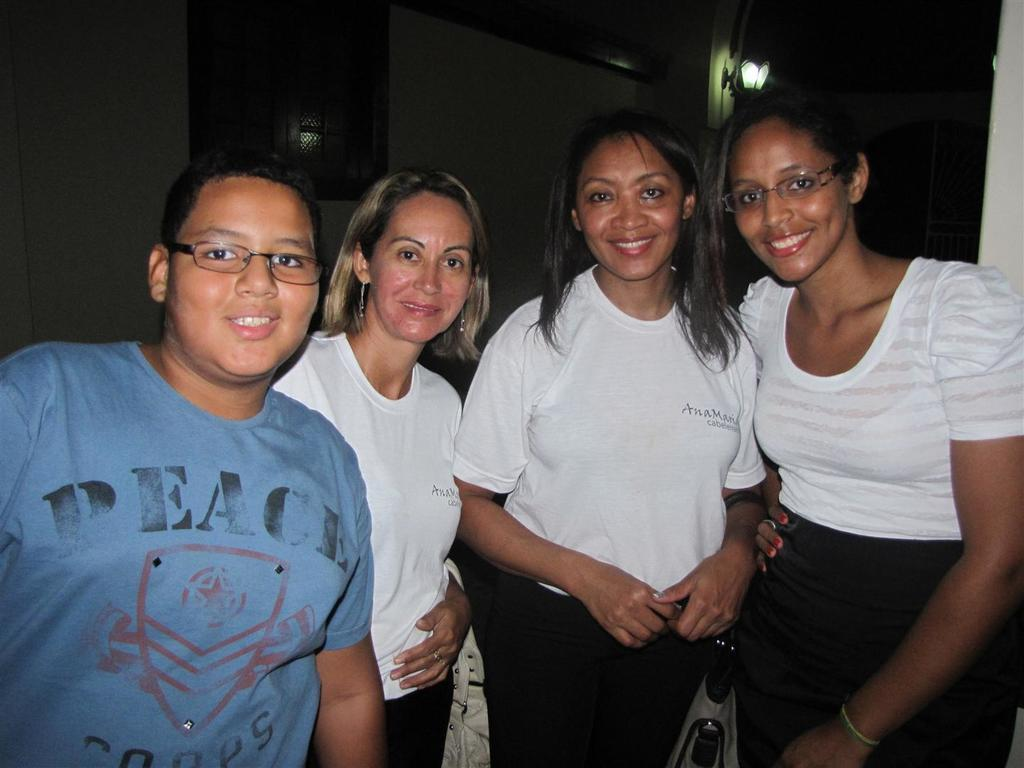What is happening in the image? There are people standing in the image. What can be seen in the background of the image? There is a wall in the background of the image. What feature does the wall have? The wall has a window. Can you describe the lighting in the image? There is light visible in the image. What type of trade is being conducted through the window in the image? There is no indication of any trade being conducted in the image; it simply shows people standing and a wall with a window. 